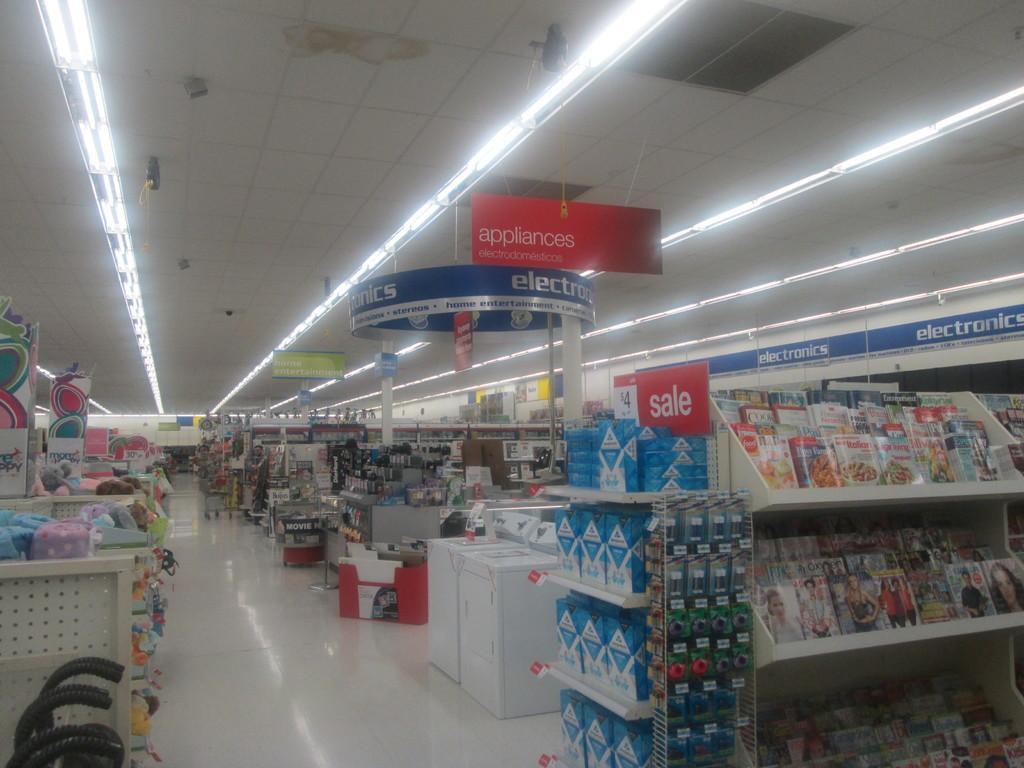<image>
Write a terse but informative summary of the picture. the inside of a store with a sign on top of one of the shelves that says 'sale' 